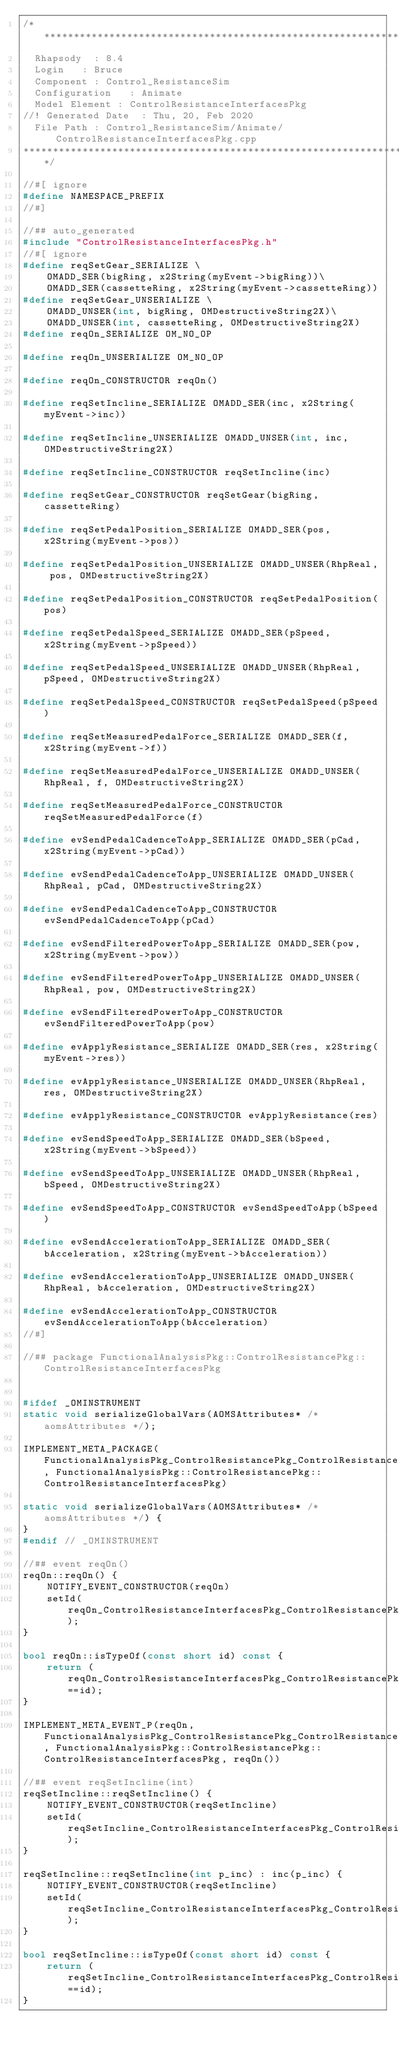Convert code to text. <code><loc_0><loc_0><loc_500><loc_500><_C++_>/********************************************************************
	Rhapsody	: 8.4 
	Login		: Bruce
	Component	: Control_ResistanceSim 
	Configuration 	: Animate
	Model Element	: ControlResistanceInterfacesPkg
//!	Generated Date	: Thu, 20, Feb 2020  
	File Path	: Control_ResistanceSim/Animate/ControlResistanceInterfacesPkg.cpp
*********************************************************************/

//#[ ignore
#define NAMESPACE_PREFIX
//#]

//## auto_generated
#include "ControlResistanceInterfacesPkg.h"
//#[ ignore
#define reqSetGear_SERIALIZE \
    OMADD_SER(bigRing, x2String(myEvent->bigRing))\
    OMADD_SER(cassetteRing, x2String(myEvent->cassetteRing))
#define reqSetGear_UNSERIALIZE \
    OMADD_UNSER(int, bigRing, OMDestructiveString2X)\
    OMADD_UNSER(int, cassetteRing, OMDestructiveString2X)
#define reqOn_SERIALIZE OM_NO_OP

#define reqOn_UNSERIALIZE OM_NO_OP

#define reqOn_CONSTRUCTOR reqOn()

#define reqSetIncline_SERIALIZE OMADD_SER(inc, x2String(myEvent->inc))

#define reqSetIncline_UNSERIALIZE OMADD_UNSER(int, inc, OMDestructiveString2X)

#define reqSetIncline_CONSTRUCTOR reqSetIncline(inc)

#define reqSetGear_CONSTRUCTOR reqSetGear(bigRing, cassetteRing)

#define reqSetPedalPosition_SERIALIZE OMADD_SER(pos, x2String(myEvent->pos))

#define reqSetPedalPosition_UNSERIALIZE OMADD_UNSER(RhpReal, pos, OMDestructiveString2X)

#define reqSetPedalPosition_CONSTRUCTOR reqSetPedalPosition(pos)

#define reqSetPedalSpeed_SERIALIZE OMADD_SER(pSpeed, x2String(myEvent->pSpeed))

#define reqSetPedalSpeed_UNSERIALIZE OMADD_UNSER(RhpReal, pSpeed, OMDestructiveString2X)

#define reqSetPedalSpeed_CONSTRUCTOR reqSetPedalSpeed(pSpeed)

#define reqSetMeasuredPedalForce_SERIALIZE OMADD_SER(f, x2String(myEvent->f))

#define reqSetMeasuredPedalForce_UNSERIALIZE OMADD_UNSER(RhpReal, f, OMDestructiveString2X)

#define reqSetMeasuredPedalForce_CONSTRUCTOR reqSetMeasuredPedalForce(f)

#define evSendPedalCadenceToApp_SERIALIZE OMADD_SER(pCad, x2String(myEvent->pCad))

#define evSendPedalCadenceToApp_UNSERIALIZE OMADD_UNSER(RhpReal, pCad, OMDestructiveString2X)

#define evSendPedalCadenceToApp_CONSTRUCTOR evSendPedalCadenceToApp(pCad)

#define evSendFilteredPowerToApp_SERIALIZE OMADD_SER(pow, x2String(myEvent->pow))

#define evSendFilteredPowerToApp_UNSERIALIZE OMADD_UNSER(RhpReal, pow, OMDestructiveString2X)

#define evSendFilteredPowerToApp_CONSTRUCTOR evSendFilteredPowerToApp(pow)

#define evApplyResistance_SERIALIZE OMADD_SER(res, x2String(myEvent->res))

#define evApplyResistance_UNSERIALIZE OMADD_UNSER(RhpReal, res, OMDestructiveString2X)

#define evApplyResistance_CONSTRUCTOR evApplyResistance(res)

#define evSendSpeedToApp_SERIALIZE OMADD_SER(bSpeed, x2String(myEvent->bSpeed))

#define evSendSpeedToApp_UNSERIALIZE OMADD_UNSER(RhpReal, bSpeed, OMDestructiveString2X)

#define evSendSpeedToApp_CONSTRUCTOR evSendSpeedToApp(bSpeed)

#define evSendAccelerationToApp_SERIALIZE OMADD_SER(bAcceleration, x2String(myEvent->bAcceleration))

#define evSendAccelerationToApp_UNSERIALIZE OMADD_UNSER(RhpReal, bAcceleration, OMDestructiveString2X)

#define evSendAccelerationToApp_CONSTRUCTOR evSendAccelerationToApp(bAcceleration)
//#]

//## package FunctionalAnalysisPkg::ControlResistancePkg::ControlResistanceInterfacesPkg


#ifdef _OMINSTRUMENT
static void serializeGlobalVars(AOMSAttributes* /* aomsAttributes */);

IMPLEMENT_META_PACKAGE(FunctionalAnalysisPkg_ControlResistancePkg_ControlResistanceInterfacesPkg, FunctionalAnalysisPkg::ControlResistancePkg::ControlResistanceInterfacesPkg)

static void serializeGlobalVars(AOMSAttributes* /* aomsAttributes */) {
}
#endif // _OMINSTRUMENT

//## event reqOn()
reqOn::reqOn() {
    NOTIFY_EVENT_CONSTRUCTOR(reqOn)
    setId(reqOn_ControlResistanceInterfacesPkg_ControlResistancePkg_FunctionalAnalysisPkg_id);
}

bool reqOn::isTypeOf(const short id) const {
    return (reqOn_ControlResistanceInterfacesPkg_ControlResistancePkg_FunctionalAnalysisPkg_id==id);
}

IMPLEMENT_META_EVENT_P(reqOn, FunctionalAnalysisPkg_ControlResistancePkg_ControlResistanceInterfacesPkg, FunctionalAnalysisPkg::ControlResistancePkg::ControlResistanceInterfacesPkg, reqOn())

//## event reqSetIncline(int)
reqSetIncline::reqSetIncline() {
    NOTIFY_EVENT_CONSTRUCTOR(reqSetIncline)
    setId(reqSetIncline_ControlResistanceInterfacesPkg_ControlResistancePkg_FunctionalAnalysisPkg_id);
}

reqSetIncline::reqSetIncline(int p_inc) : inc(p_inc) {
    NOTIFY_EVENT_CONSTRUCTOR(reqSetIncline)
    setId(reqSetIncline_ControlResistanceInterfacesPkg_ControlResistancePkg_FunctionalAnalysisPkg_id);
}

bool reqSetIncline::isTypeOf(const short id) const {
    return (reqSetIncline_ControlResistanceInterfacesPkg_ControlResistancePkg_FunctionalAnalysisPkg_id==id);
}
</code> 